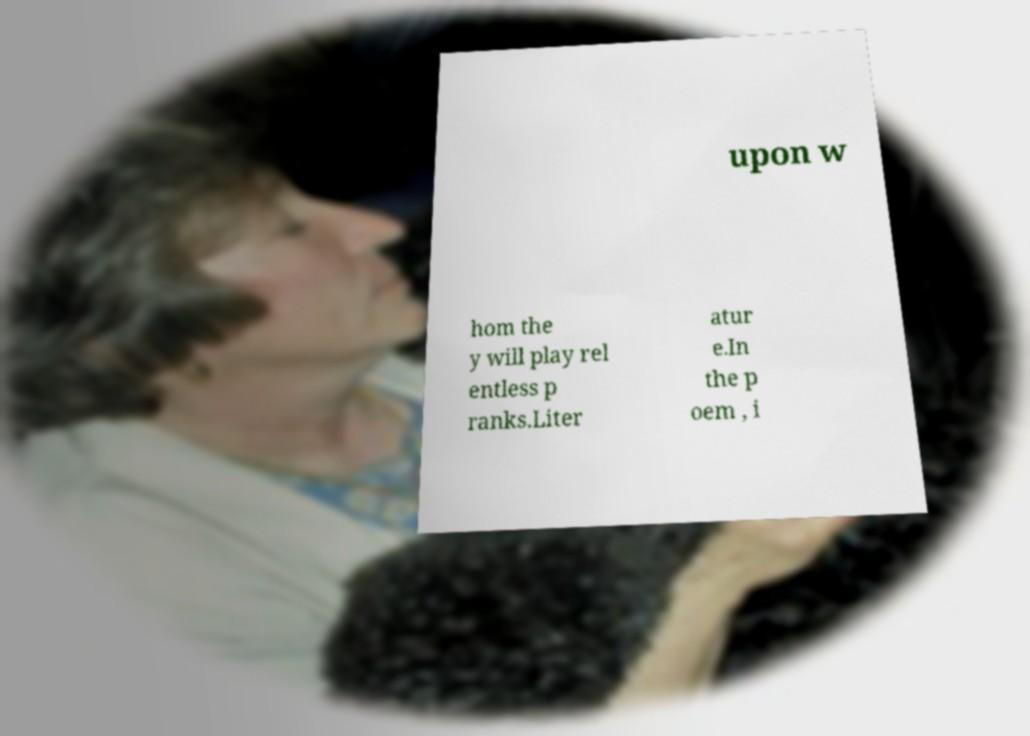I need the written content from this picture converted into text. Can you do that? upon w hom the y will play rel entless p ranks.Liter atur e.In the p oem , i 